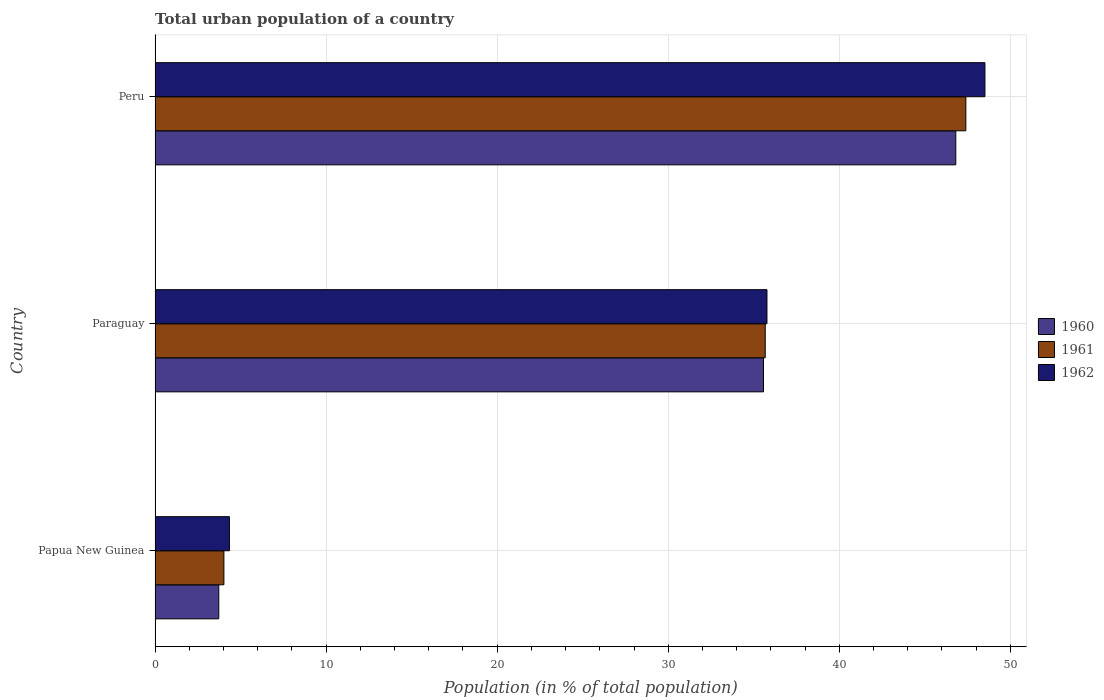How many different coloured bars are there?
Your response must be concise. 3. How many groups of bars are there?
Your response must be concise. 3. Are the number of bars on each tick of the Y-axis equal?
Offer a very short reply. Yes. How many bars are there on the 1st tick from the top?
Offer a terse response. 3. What is the label of the 3rd group of bars from the top?
Offer a terse response. Papua New Guinea. What is the urban population in 1961 in Papua New Guinea?
Your response must be concise. 4.02. Across all countries, what is the maximum urban population in 1962?
Keep it short and to the point. 48.51. Across all countries, what is the minimum urban population in 1961?
Provide a short and direct response. 4.02. In which country was the urban population in 1961 maximum?
Give a very brief answer. Peru. In which country was the urban population in 1960 minimum?
Offer a very short reply. Papua New Guinea. What is the total urban population in 1960 in the graph?
Make the answer very short. 86.11. What is the difference between the urban population in 1961 in Paraguay and that in Peru?
Provide a short and direct response. -11.73. What is the difference between the urban population in 1962 in Peru and the urban population in 1961 in Paraguay?
Your answer should be compact. 12.84. What is the average urban population in 1962 per country?
Keep it short and to the point. 29.54. What is the difference between the urban population in 1962 and urban population in 1961 in Paraguay?
Make the answer very short. 0.1. What is the ratio of the urban population in 1960 in Paraguay to that in Peru?
Provide a succinct answer. 0.76. Is the urban population in 1961 in Papua New Guinea less than that in Peru?
Offer a very short reply. Yes. What is the difference between the highest and the second highest urban population in 1962?
Provide a short and direct response. 12.74. What is the difference between the highest and the lowest urban population in 1960?
Offer a very short reply. 43.09. In how many countries, is the urban population in 1961 greater than the average urban population in 1961 taken over all countries?
Give a very brief answer. 2. What does the 2nd bar from the top in Peru represents?
Your answer should be compact. 1961. Are all the bars in the graph horizontal?
Ensure brevity in your answer.  Yes. Does the graph contain any zero values?
Your answer should be very brief. No. Where does the legend appear in the graph?
Offer a very short reply. Center right. How many legend labels are there?
Your answer should be compact. 3. What is the title of the graph?
Your response must be concise. Total urban population of a country. What is the label or title of the X-axis?
Your response must be concise. Population (in % of total population). What is the Population (in % of total population) of 1960 in Papua New Guinea?
Offer a very short reply. 3.73. What is the Population (in % of total population) in 1961 in Papua New Guinea?
Ensure brevity in your answer.  4.02. What is the Population (in % of total population) of 1962 in Papua New Guinea?
Give a very brief answer. 4.35. What is the Population (in % of total population) in 1960 in Paraguay?
Provide a succinct answer. 35.57. What is the Population (in % of total population) in 1961 in Paraguay?
Your answer should be very brief. 35.67. What is the Population (in % of total population) in 1962 in Paraguay?
Provide a short and direct response. 35.77. What is the Population (in % of total population) of 1960 in Peru?
Provide a succinct answer. 46.81. What is the Population (in % of total population) in 1961 in Peru?
Give a very brief answer. 47.4. What is the Population (in % of total population) in 1962 in Peru?
Offer a terse response. 48.51. Across all countries, what is the maximum Population (in % of total population) in 1960?
Give a very brief answer. 46.81. Across all countries, what is the maximum Population (in % of total population) in 1961?
Keep it short and to the point. 47.4. Across all countries, what is the maximum Population (in % of total population) of 1962?
Offer a terse response. 48.51. Across all countries, what is the minimum Population (in % of total population) in 1960?
Offer a very short reply. 3.73. Across all countries, what is the minimum Population (in % of total population) in 1961?
Offer a terse response. 4.02. Across all countries, what is the minimum Population (in % of total population) in 1962?
Ensure brevity in your answer.  4.35. What is the total Population (in % of total population) of 1960 in the graph?
Your answer should be compact. 86.11. What is the total Population (in % of total population) of 1961 in the graph?
Your response must be concise. 87.09. What is the total Population (in % of total population) of 1962 in the graph?
Ensure brevity in your answer.  88.63. What is the difference between the Population (in % of total population) of 1960 in Papua New Guinea and that in Paraguay?
Your answer should be very brief. -31.84. What is the difference between the Population (in % of total population) of 1961 in Papua New Guinea and that in Paraguay?
Your answer should be very brief. -31.65. What is the difference between the Population (in % of total population) in 1962 in Papua New Guinea and that in Paraguay?
Your answer should be compact. -31.42. What is the difference between the Population (in % of total population) of 1960 in Papua New Guinea and that in Peru?
Keep it short and to the point. -43.09. What is the difference between the Population (in % of total population) of 1961 in Papua New Guinea and that in Peru?
Your answer should be very brief. -43.37. What is the difference between the Population (in % of total population) in 1962 in Papua New Guinea and that in Peru?
Provide a succinct answer. -44.17. What is the difference between the Population (in % of total population) of 1960 in Paraguay and that in Peru?
Keep it short and to the point. -11.24. What is the difference between the Population (in % of total population) in 1961 in Paraguay and that in Peru?
Provide a succinct answer. -11.73. What is the difference between the Population (in % of total population) of 1962 in Paraguay and that in Peru?
Make the answer very short. -12.74. What is the difference between the Population (in % of total population) in 1960 in Papua New Guinea and the Population (in % of total population) in 1961 in Paraguay?
Your answer should be very brief. -31.95. What is the difference between the Population (in % of total population) in 1960 in Papua New Guinea and the Population (in % of total population) in 1962 in Paraguay?
Your answer should be very brief. -32.05. What is the difference between the Population (in % of total population) in 1961 in Papua New Guinea and the Population (in % of total population) in 1962 in Paraguay?
Offer a terse response. -31.75. What is the difference between the Population (in % of total population) of 1960 in Papua New Guinea and the Population (in % of total population) of 1961 in Peru?
Provide a short and direct response. -43.67. What is the difference between the Population (in % of total population) in 1960 in Papua New Guinea and the Population (in % of total population) in 1962 in Peru?
Ensure brevity in your answer.  -44.79. What is the difference between the Population (in % of total population) in 1961 in Papua New Guinea and the Population (in % of total population) in 1962 in Peru?
Make the answer very short. -44.49. What is the difference between the Population (in % of total population) of 1960 in Paraguay and the Population (in % of total population) of 1961 in Peru?
Ensure brevity in your answer.  -11.83. What is the difference between the Population (in % of total population) of 1960 in Paraguay and the Population (in % of total population) of 1962 in Peru?
Your answer should be very brief. -12.95. What is the difference between the Population (in % of total population) in 1961 in Paraguay and the Population (in % of total population) in 1962 in Peru?
Give a very brief answer. -12.84. What is the average Population (in % of total population) of 1960 per country?
Give a very brief answer. 28.7. What is the average Population (in % of total population) in 1961 per country?
Keep it short and to the point. 29.03. What is the average Population (in % of total population) in 1962 per country?
Your response must be concise. 29.54. What is the difference between the Population (in % of total population) in 1960 and Population (in % of total population) in 1961 in Papua New Guinea?
Give a very brief answer. -0.3. What is the difference between the Population (in % of total population) in 1960 and Population (in % of total population) in 1962 in Papua New Guinea?
Your answer should be compact. -0.62. What is the difference between the Population (in % of total population) in 1961 and Population (in % of total population) in 1962 in Papua New Guinea?
Give a very brief answer. -0.32. What is the difference between the Population (in % of total population) in 1960 and Population (in % of total population) in 1961 in Paraguay?
Your response must be concise. -0.1. What is the difference between the Population (in % of total population) of 1960 and Population (in % of total population) of 1962 in Paraguay?
Ensure brevity in your answer.  -0.2. What is the difference between the Population (in % of total population) of 1961 and Population (in % of total population) of 1962 in Paraguay?
Your answer should be compact. -0.1. What is the difference between the Population (in % of total population) of 1960 and Population (in % of total population) of 1961 in Peru?
Your response must be concise. -0.59. What is the difference between the Population (in % of total population) of 1960 and Population (in % of total population) of 1962 in Peru?
Ensure brevity in your answer.  -1.7. What is the difference between the Population (in % of total population) of 1961 and Population (in % of total population) of 1962 in Peru?
Keep it short and to the point. -1.12. What is the ratio of the Population (in % of total population) in 1960 in Papua New Guinea to that in Paraguay?
Provide a short and direct response. 0.1. What is the ratio of the Population (in % of total population) in 1961 in Papua New Guinea to that in Paraguay?
Provide a succinct answer. 0.11. What is the ratio of the Population (in % of total population) in 1962 in Papua New Guinea to that in Paraguay?
Keep it short and to the point. 0.12. What is the ratio of the Population (in % of total population) in 1960 in Papua New Guinea to that in Peru?
Keep it short and to the point. 0.08. What is the ratio of the Population (in % of total population) in 1961 in Papua New Guinea to that in Peru?
Keep it short and to the point. 0.08. What is the ratio of the Population (in % of total population) of 1962 in Papua New Guinea to that in Peru?
Make the answer very short. 0.09. What is the ratio of the Population (in % of total population) of 1960 in Paraguay to that in Peru?
Your answer should be very brief. 0.76. What is the ratio of the Population (in % of total population) in 1961 in Paraguay to that in Peru?
Offer a very short reply. 0.75. What is the ratio of the Population (in % of total population) in 1962 in Paraguay to that in Peru?
Provide a succinct answer. 0.74. What is the difference between the highest and the second highest Population (in % of total population) of 1960?
Your answer should be compact. 11.24. What is the difference between the highest and the second highest Population (in % of total population) in 1961?
Make the answer very short. 11.73. What is the difference between the highest and the second highest Population (in % of total population) of 1962?
Keep it short and to the point. 12.74. What is the difference between the highest and the lowest Population (in % of total population) of 1960?
Offer a terse response. 43.09. What is the difference between the highest and the lowest Population (in % of total population) of 1961?
Offer a very short reply. 43.37. What is the difference between the highest and the lowest Population (in % of total population) of 1962?
Make the answer very short. 44.17. 